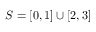Convert formula to latex. <formula><loc_0><loc_0><loc_500><loc_500>S = [ 0 , 1 ] \cup [ 2 , 3 ]</formula> 